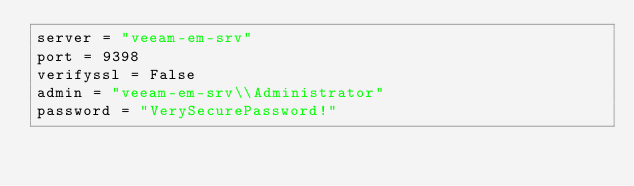<code> <loc_0><loc_0><loc_500><loc_500><_Python_>server = "veeam-em-srv"
port = 9398
verifyssl = False
admin = "veeam-em-srv\\Administrator"
password = "VerySecurePassword!"
</code> 